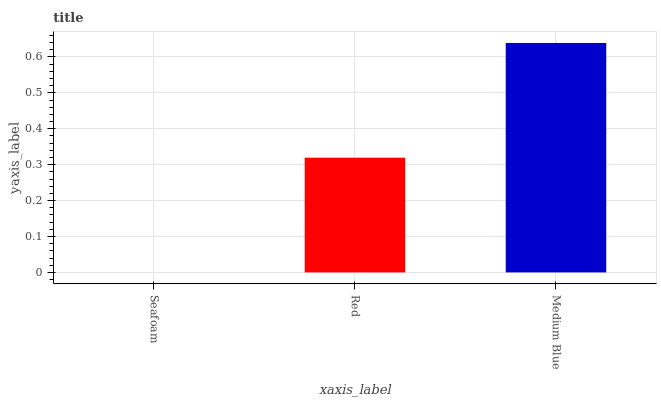Is Red the minimum?
Answer yes or no. No. Is Red the maximum?
Answer yes or no. No. Is Red greater than Seafoam?
Answer yes or no. Yes. Is Seafoam less than Red?
Answer yes or no. Yes. Is Seafoam greater than Red?
Answer yes or no. No. Is Red less than Seafoam?
Answer yes or no. No. Is Red the high median?
Answer yes or no. Yes. Is Red the low median?
Answer yes or no. Yes. Is Medium Blue the high median?
Answer yes or no. No. Is Medium Blue the low median?
Answer yes or no. No. 